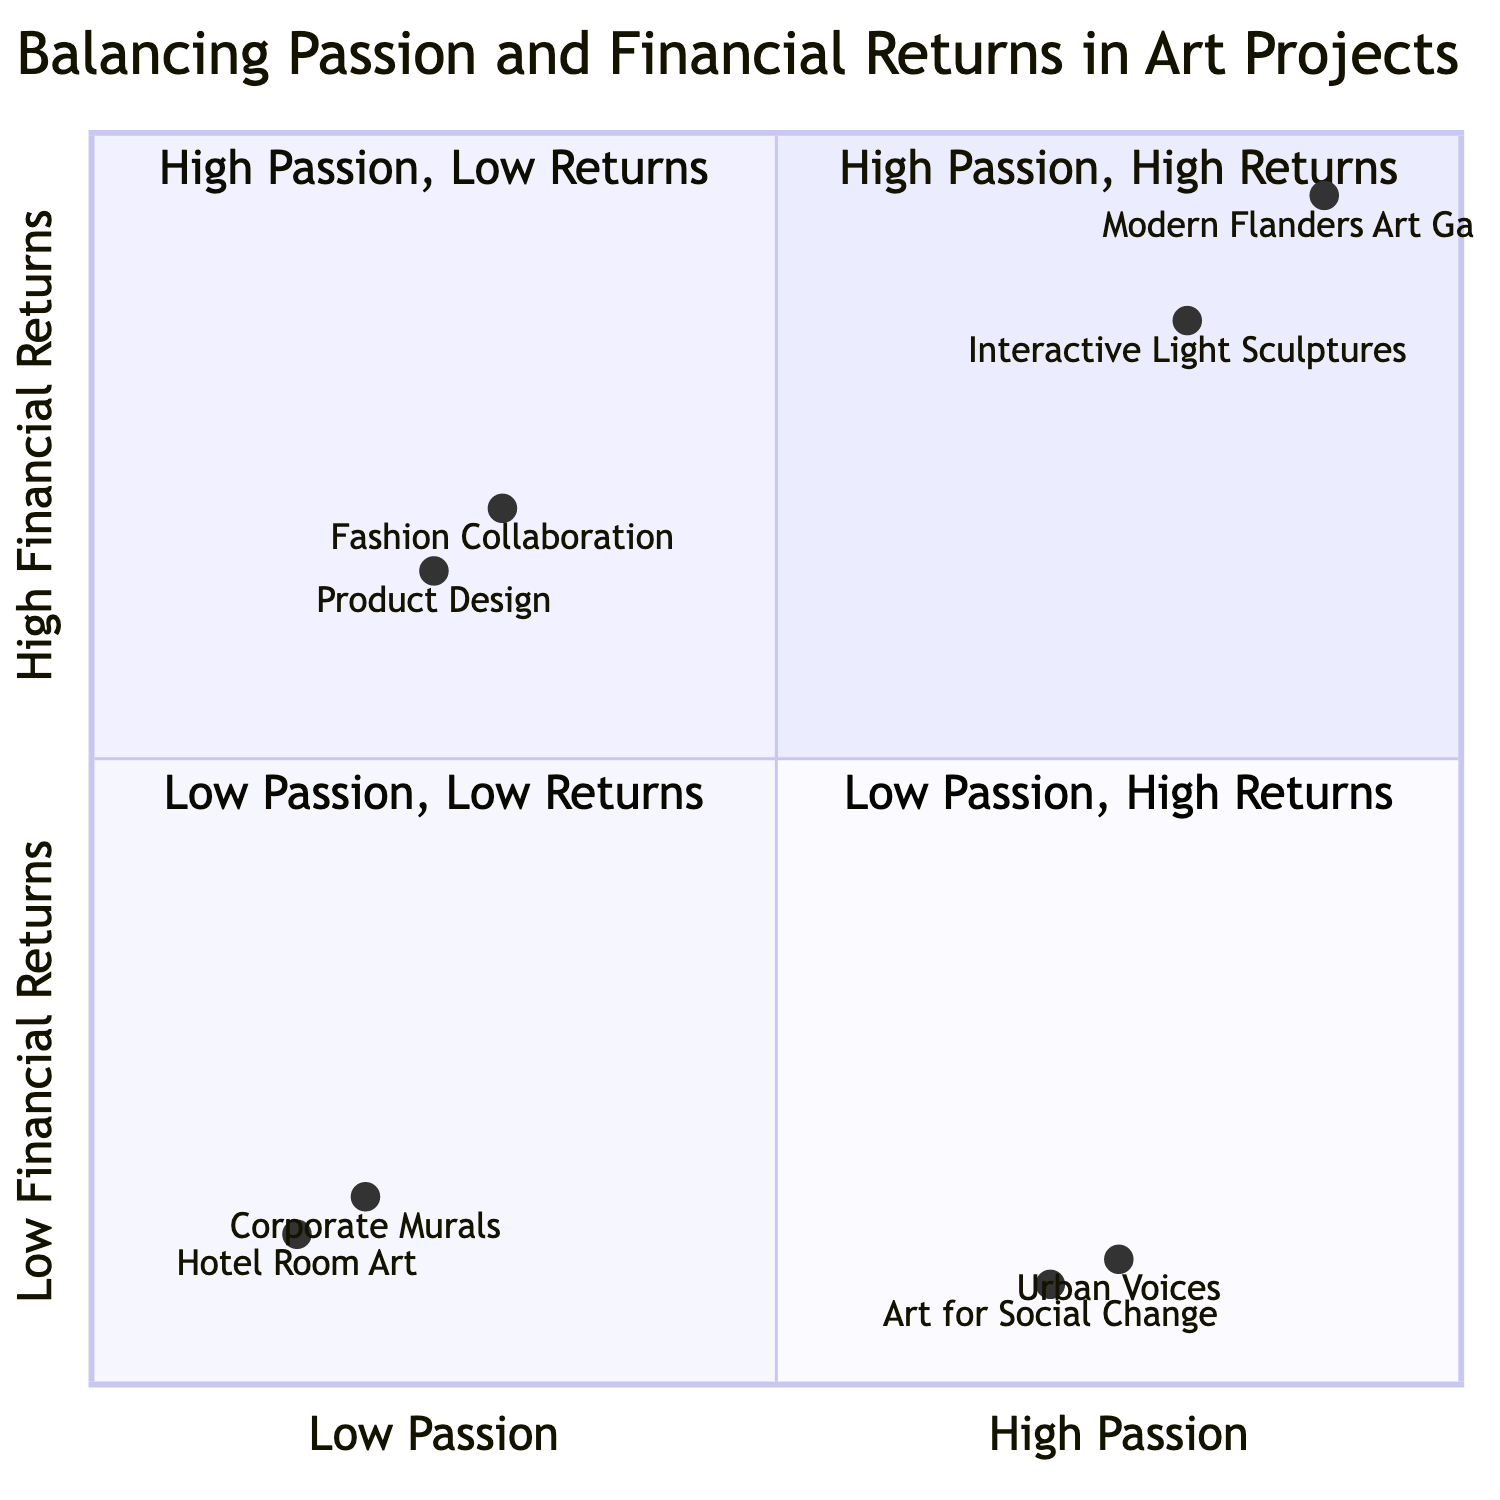What project has the highest financial return? The project with the highest financial return is "Modern Flanders Art Gallery," which has €12,000.
Answer: Modern Flanders Art Gallery Which quadrant contains projects with high passion and high financial returns? The quadrant labeled "High Passion, High Returns" contains projects with both high passion and high financial returns. The projects listed in this quadrant are "Interactive Light Sculptures" and "Modern Flanders Art Gallery."
Answer: High Passion, High Returns How many projects are categorized under "Low Passion - Low Financial Returns"? There are two projects listed in the "Low Passion - Low Financial Returns" quadrant: "Corporate Murals" and "Hotel Room Art." Therefore, the total count is 2.
Answer: 2 What is the time investment for the "Interactive Light Sculptures"? The time investment for the "Interactive Light Sculptures" project is 250 hours.
Answer: 250 hours In which quadrant would you classify "Art for Social Change"? "Art for Social Change" is classified in the "High Passion - Low Financial Returns" quadrant due to its significant time investment but comparatively low financial returns.
Answer: High Passion - Low Financial Returns Which project has the lowest financial return? The project with the lowest financial return is "Art for Social Change," which has €850.
Answer: Art for Social Change How does the financial return of "Fashion Collaboration" compare to "Product Design"? "Fashion Collaboration" has a financial return of €8,000, whereas "Product Design" has a return of €7,500. Therefore, "Fashion Collaboration" has a higher financial return than "Product Design."
Answer: Higher How many projects are in the "Low Passion - High Financial Returns" quadrant? There are two projects under the "Low Passion - High Financial Returns" quadrant, which are "Fashion Collaboration" and "Product Design."
Answer: 2 Which type of projects might prioritize financial success over passion? Projects categorized under "Low Passion - High Financial Returns" prioritize financial success over passion, as indicated by their high financial returns but low passion levels.
Answer: Low Passion - High Financial Returns 